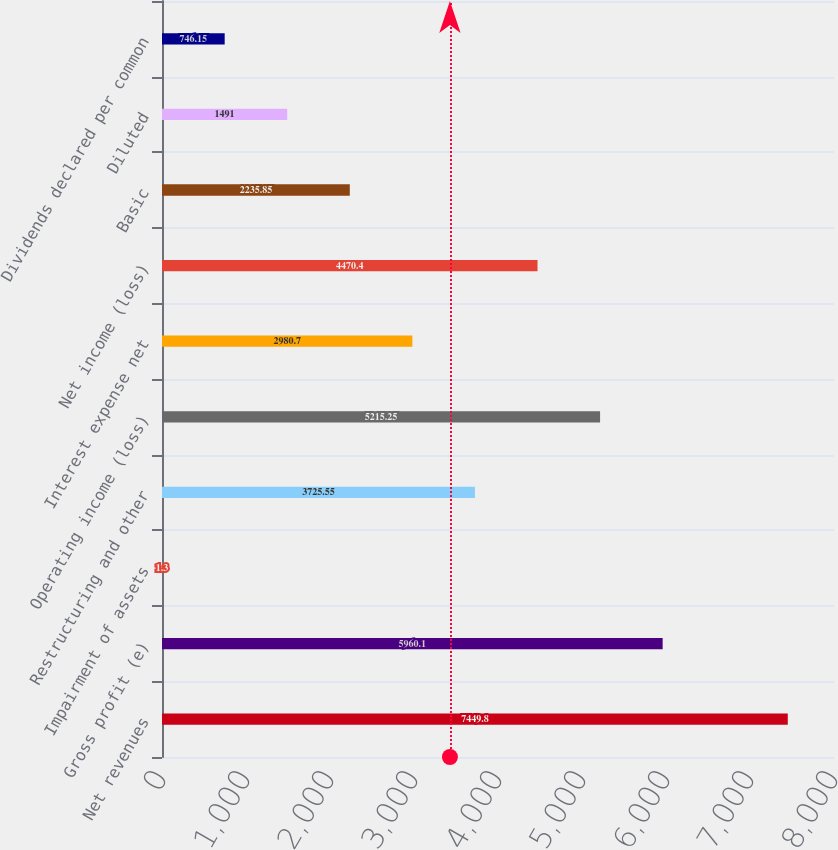Convert chart. <chart><loc_0><loc_0><loc_500><loc_500><bar_chart><fcel>Net revenues<fcel>Gross profit (e)<fcel>Impairment of assets<fcel>Restructuring and other<fcel>Operating income (loss)<fcel>Interest expense net<fcel>Net income (loss)<fcel>Basic<fcel>Diluted<fcel>Dividends declared per common<nl><fcel>7449.8<fcel>5960.1<fcel>1.3<fcel>3725.55<fcel>5215.25<fcel>2980.7<fcel>4470.4<fcel>2235.85<fcel>1491<fcel>746.15<nl></chart> 